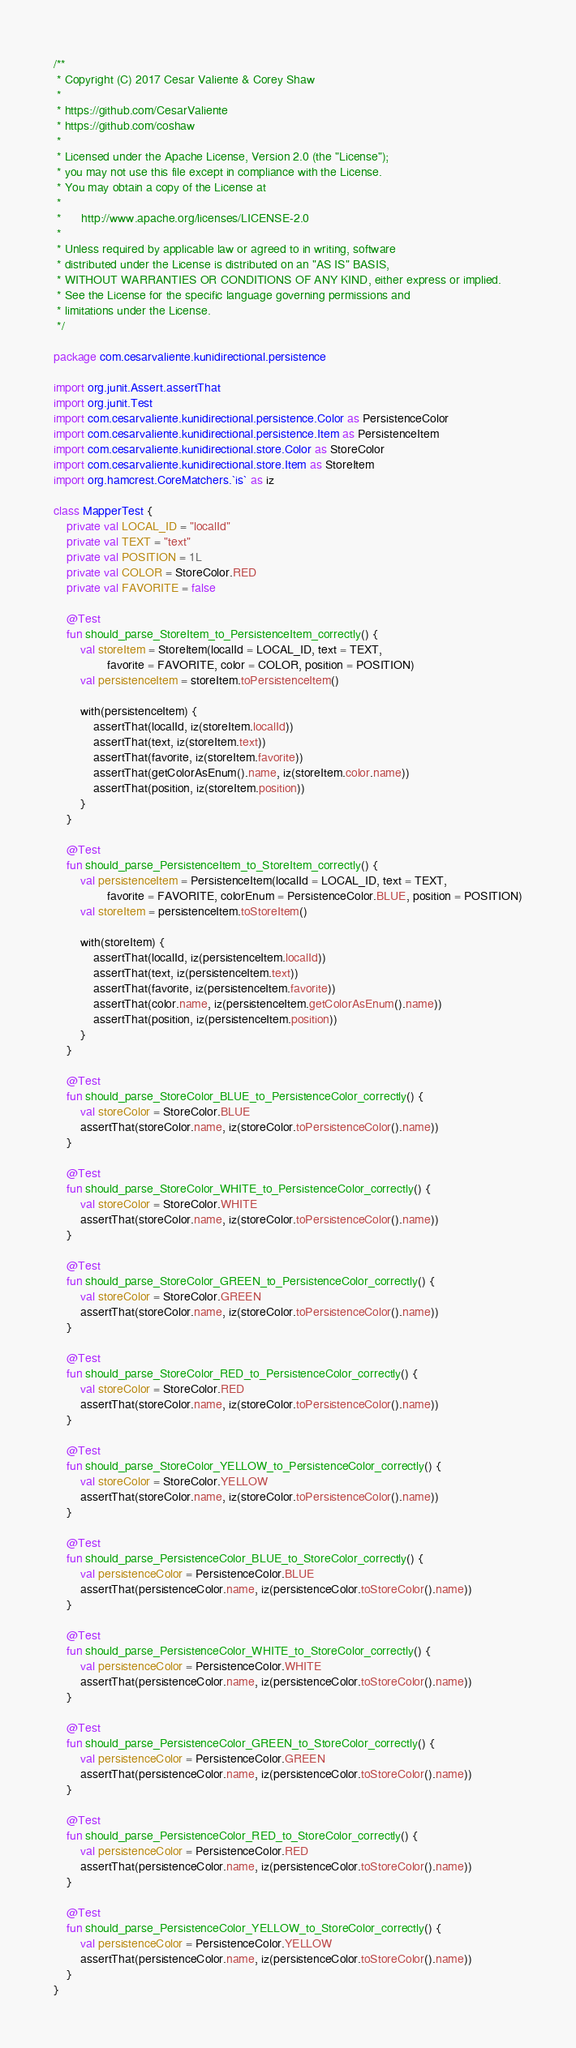<code> <loc_0><loc_0><loc_500><loc_500><_Kotlin_>/**
 * Copyright (C) 2017 Cesar Valiente & Corey Shaw
 *
 * https://github.com/CesarValiente
 * https://github.com/coshaw
 *
 * Licensed under the Apache License, Version 2.0 (the "License");
 * you may not use this file except in compliance with the License.
 * You may obtain a copy of the License at
 *
 *      http://www.apache.org/licenses/LICENSE-2.0
 *
 * Unless required by applicable law or agreed to in writing, software
 * distributed under the License is distributed on an "AS IS" BASIS,
 * WITHOUT WARRANTIES OR CONDITIONS OF ANY KIND, either express or implied.
 * See the License for the specific language governing permissions and
 * limitations under the License.
 */

package com.cesarvaliente.kunidirectional.persistence

import org.junit.Assert.assertThat
import org.junit.Test
import com.cesarvaliente.kunidirectional.persistence.Color as PersistenceColor
import com.cesarvaliente.kunidirectional.persistence.Item as PersistenceItem
import com.cesarvaliente.kunidirectional.store.Color as StoreColor
import com.cesarvaliente.kunidirectional.store.Item as StoreItem
import org.hamcrest.CoreMatchers.`is` as iz

class MapperTest {
    private val LOCAL_ID = "localId"
    private val TEXT = "text"
    private val POSITION = 1L
    private val COLOR = StoreColor.RED
    private val FAVORITE = false

    @Test
    fun should_parse_StoreItem_to_PersistenceItem_correctly() {
        val storeItem = StoreItem(localId = LOCAL_ID, text = TEXT,
                favorite = FAVORITE, color = COLOR, position = POSITION)
        val persistenceItem = storeItem.toPersistenceItem()

        with(persistenceItem) {
            assertThat(localId, iz(storeItem.localId))
            assertThat(text, iz(storeItem.text))
            assertThat(favorite, iz(storeItem.favorite))
            assertThat(getColorAsEnum().name, iz(storeItem.color.name))
            assertThat(position, iz(storeItem.position))
        }
    }

    @Test
    fun should_parse_PersistenceItem_to_StoreItem_correctly() {
        val persistenceItem = PersistenceItem(localId = LOCAL_ID, text = TEXT,
                favorite = FAVORITE, colorEnum = PersistenceColor.BLUE, position = POSITION)
        val storeItem = persistenceItem.toStoreItem()

        with(storeItem) {
            assertThat(localId, iz(persistenceItem.localId))
            assertThat(text, iz(persistenceItem.text))
            assertThat(favorite, iz(persistenceItem.favorite))
            assertThat(color.name, iz(persistenceItem.getColorAsEnum().name))
            assertThat(position, iz(persistenceItem.position))
        }
    }

    @Test
    fun should_parse_StoreColor_BLUE_to_PersistenceColor_correctly() {
        val storeColor = StoreColor.BLUE
        assertThat(storeColor.name, iz(storeColor.toPersistenceColor().name))
    }

    @Test
    fun should_parse_StoreColor_WHITE_to_PersistenceColor_correctly() {
        val storeColor = StoreColor.WHITE
        assertThat(storeColor.name, iz(storeColor.toPersistenceColor().name))
    }

    @Test
    fun should_parse_StoreColor_GREEN_to_PersistenceColor_correctly() {
        val storeColor = StoreColor.GREEN
        assertThat(storeColor.name, iz(storeColor.toPersistenceColor().name))
    }

    @Test
    fun should_parse_StoreColor_RED_to_PersistenceColor_correctly() {
        val storeColor = StoreColor.RED
        assertThat(storeColor.name, iz(storeColor.toPersistenceColor().name))
    }

    @Test
    fun should_parse_StoreColor_YELLOW_to_PersistenceColor_correctly() {
        val storeColor = StoreColor.YELLOW
        assertThat(storeColor.name, iz(storeColor.toPersistenceColor().name))
    }

    @Test
    fun should_parse_PersistenceColor_BLUE_to_StoreColor_correctly() {
        val persistenceColor = PersistenceColor.BLUE
        assertThat(persistenceColor.name, iz(persistenceColor.toStoreColor().name))
    }

    @Test
    fun should_parse_PersistenceColor_WHITE_to_StoreColor_correctly() {
        val persistenceColor = PersistenceColor.WHITE
        assertThat(persistenceColor.name, iz(persistenceColor.toStoreColor().name))
    }

    @Test
    fun should_parse_PersistenceColor_GREEN_to_StoreColor_correctly() {
        val persistenceColor = PersistenceColor.GREEN
        assertThat(persistenceColor.name, iz(persistenceColor.toStoreColor().name))
    }

    @Test
    fun should_parse_PersistenceColor_RED_to_StoreColor_correctly() {
        val persistenceColor = PersistenceColor.RED
        assertThat(persistenceColor.name, iz(persistenceColor.toStoreColor().name))
    }

    @Test
    fun should_parse_PersistenceColor_YELLOW_to_StoreColor_correctly() {
        val persistenceColor = PersistenceColor.YELLOW
        assertThat(persistenceColor.name, iz(persistenceColor.toStoreColor().name))
    }
}</code> 